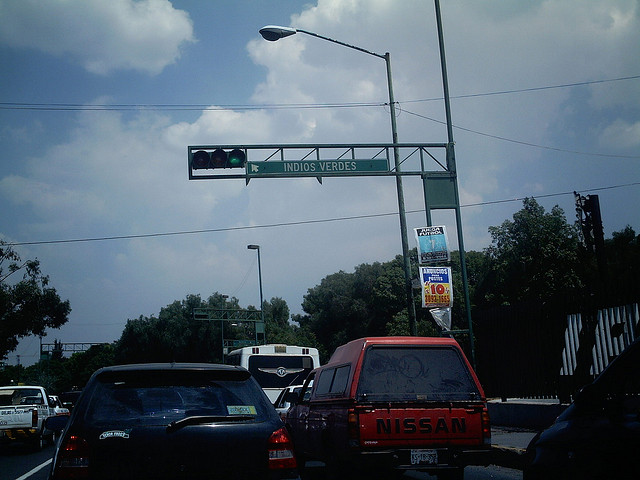Can you describe the traffic signal shown in the image? Certainly. The image shows a traffic signal mounted overhead on a metal structure. The signal has three aspects, and it is currently displaying the green light, indicating that vehicles are allowed to proceed. 